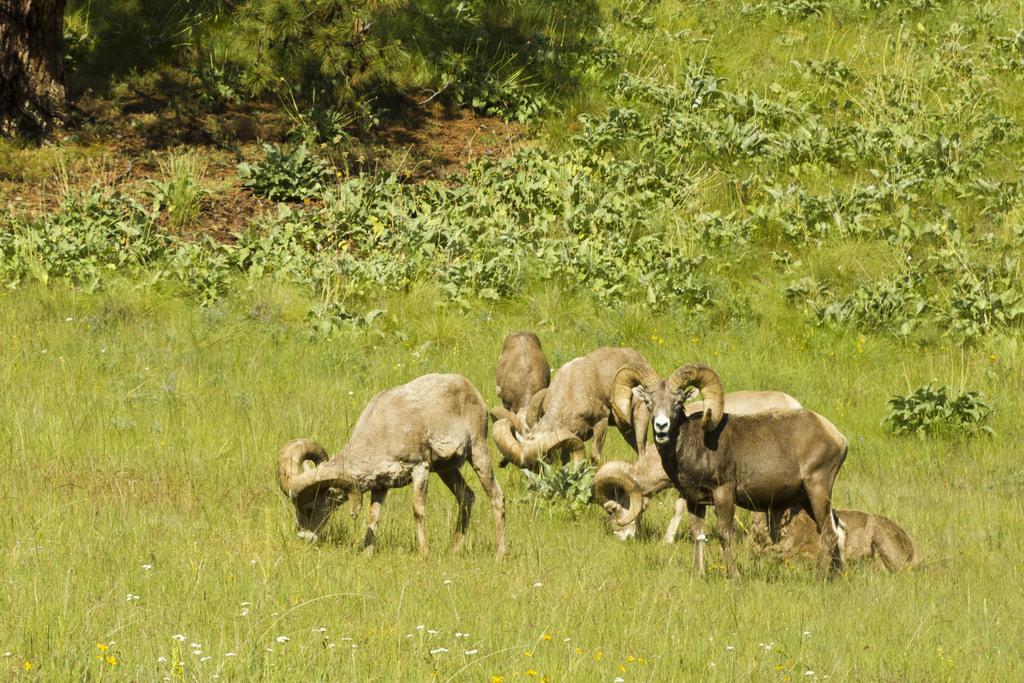Can you describe this image briefly? Here we can see bighorn sheep standing on the ground and there is an animal sitting on the grass. In the background we can see plants. 